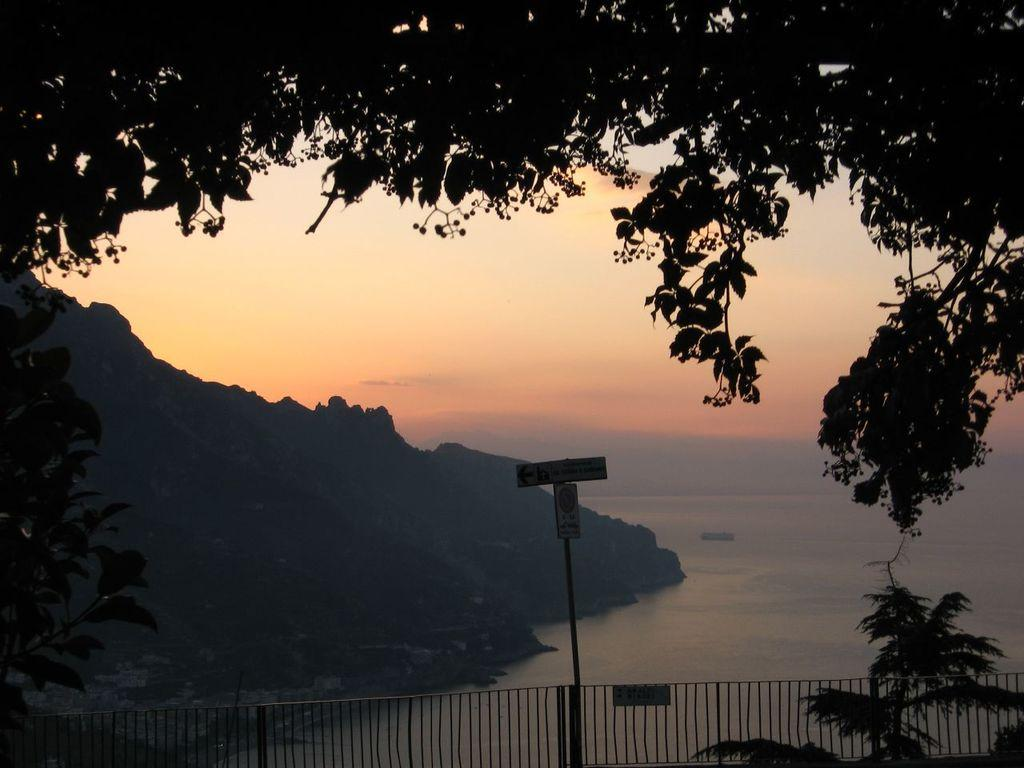What type of landscape can be seen in the image? There are hills in the image. What natural element is present in the image? There is water visible in the image. What type of vegetation is in the image? There are trees in the image. What man-made structure is present in the image? There is fencing in the image. What type of vehicle is in the image? There is a ship in the image. What is visible in the sky in the image? The sky is visible in the image, and there are clouds in the sky. How many geese are resting on the beds in the image? There are no geese or beds present in the image. 